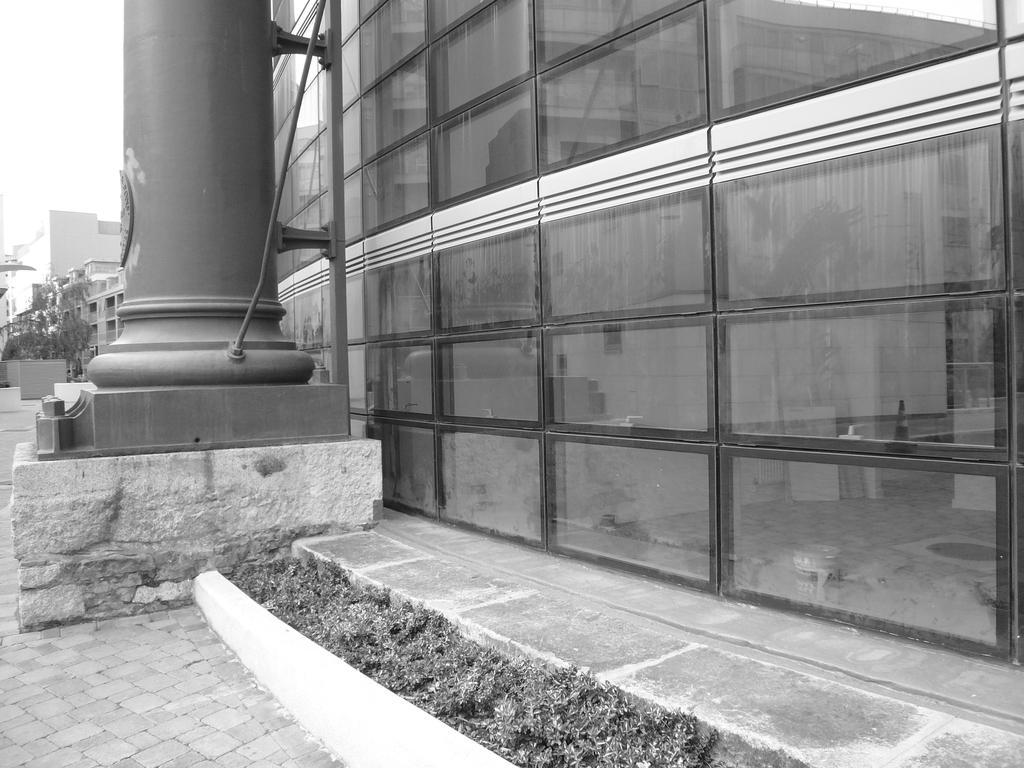Can you describe this image briefly? This is a black and white image. On the left side of the image we can see pillar. On the right side of the image there is building and grass. In the background we can see trees, plants, buildings and sky. 